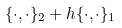Convert formula to latex. <formula><loc_0><loc_0><loc_500><loc_500>\{ \cdot , \cdot \} _ { 2 } + h \{ \cdot , \cdot \} _ { 1 }</formula> 